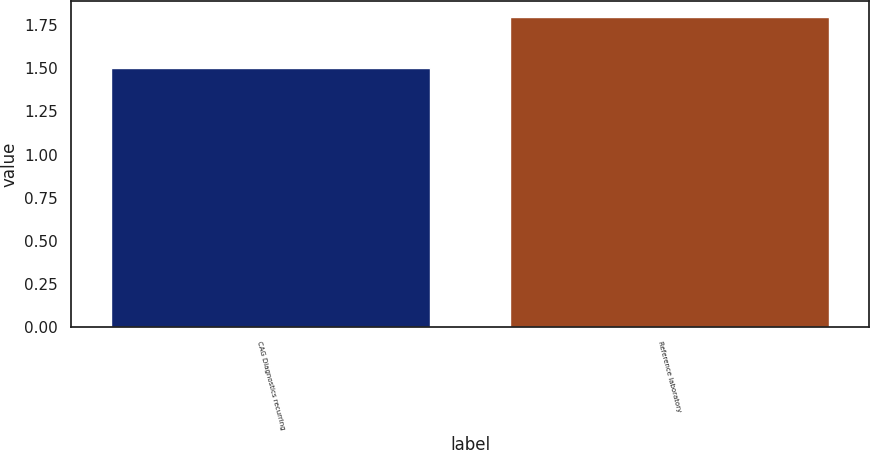Convert chart to OTSL. <chart><loc_0><loc_0><loc_500><loc_500><bar_chart><fcel>CAG Diagnostics recurring<fcel>Reference laboratory<nl><fcel>1.5<fcel>1.8<nl></chart> 